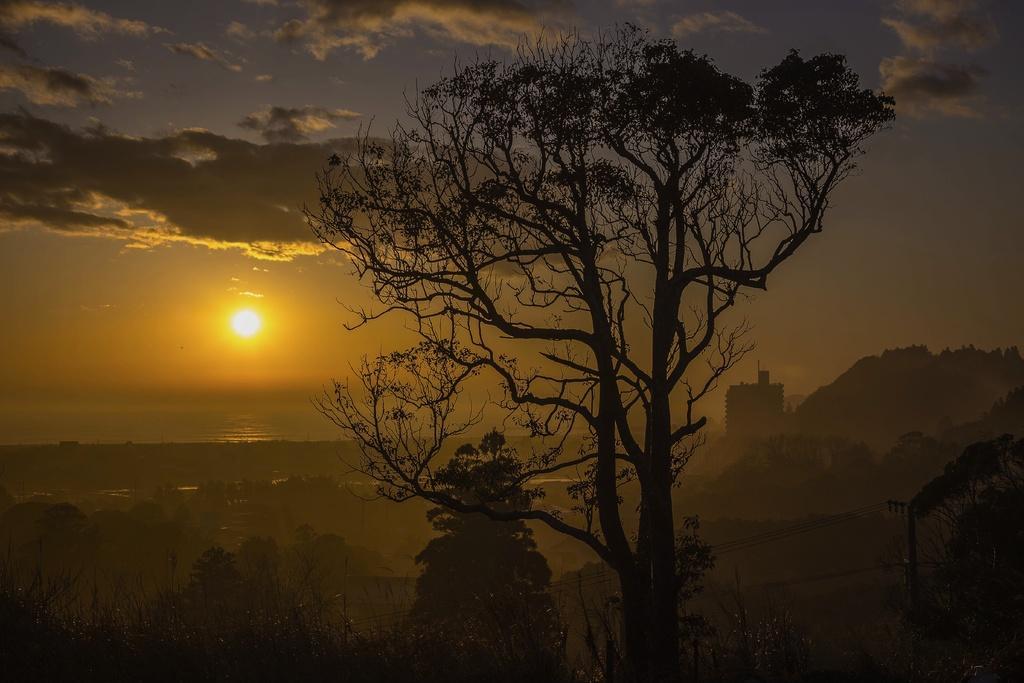In one or two sentences, can you explain what this image depicts? In this image we can see there is the building, trees, current pole, moon and the sky. 